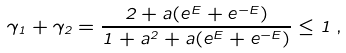<formula> <loc_0><loc_0><loc_500><loc_500>\gamma _ { 1 } + \gamma _ { 2 } = \frac { 2 + a ( e ^ { E } + e ^ { - E } ) } { 1 + a ^ { 2 } + a ( e ^ { E } + e ^ { - E } ) } \leq 1 \, ,</formula> 